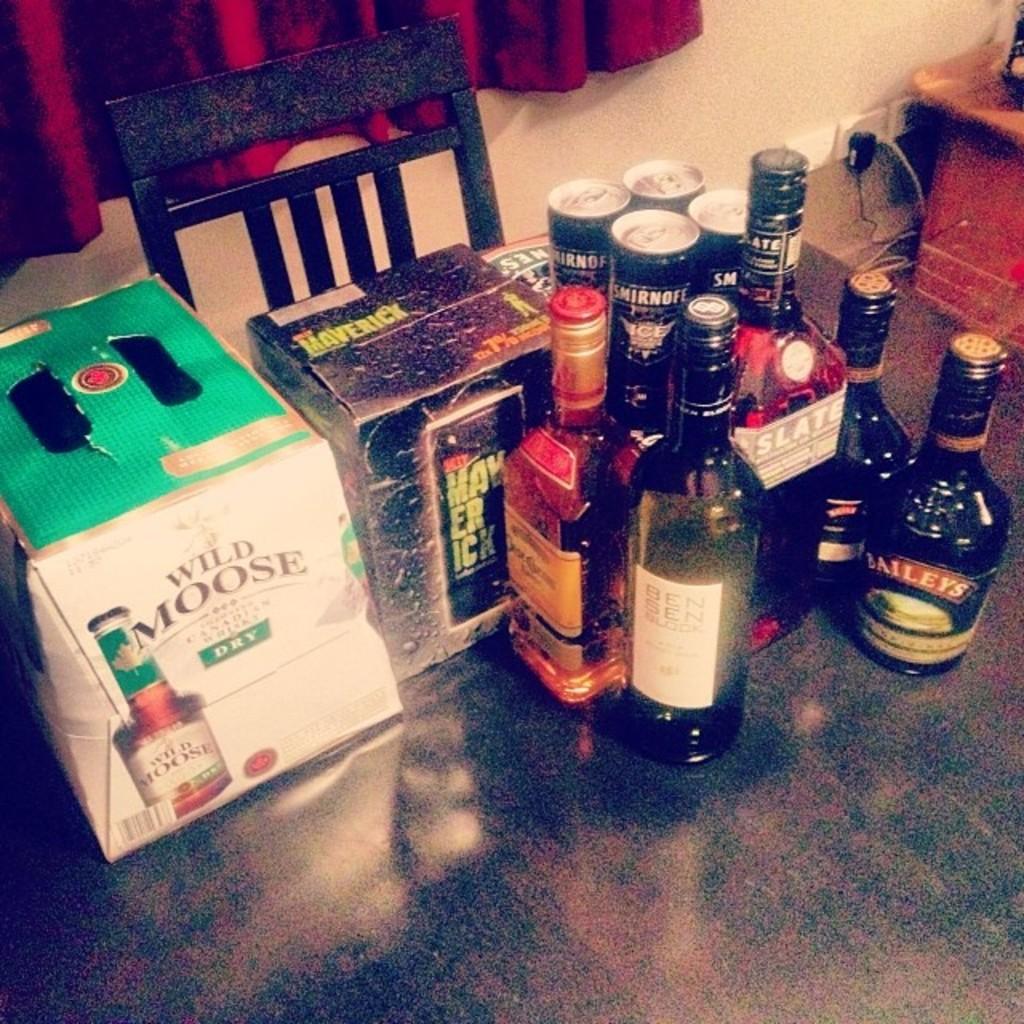What brand of alcohol is in the box on the left?
Provide a succinct answer. Wild moose. 